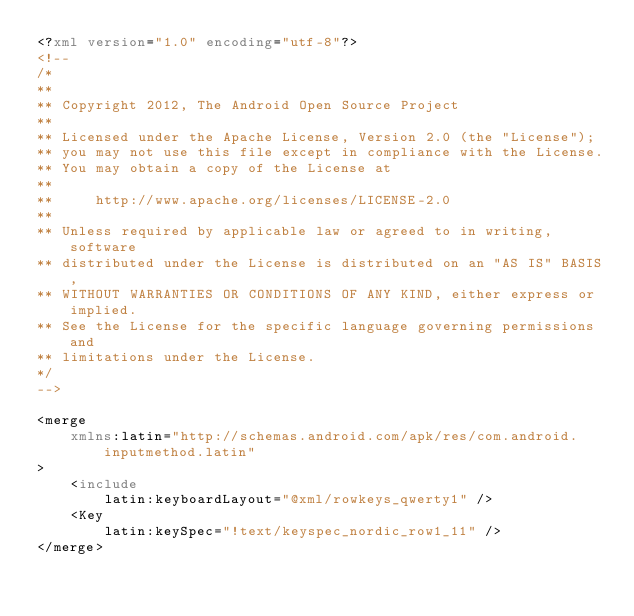<code> <loc_0><loc_0><loc_500><loc_500><_XML_><?xml version="1.0" encoding="utf-8"?>
<!--
/*
**
** Copyright 2012, The Android Open Source Project
**
** Licensed under the Apache License, Version 2.0 (the "License");
** you may not use this file except in compliance with the License.
** You may obtain a copy of the License at
**
**     http://www.apache.org/licenses/LICENSE-2.0
**
** Unless required by applicable law or agreed to in writing, software
** distributed under the License is distributed on an "AS IS" BASIS,
** WITHOUT WARRANTIES OR CONDITIONS OF ANY KIND, either express or implied.
** See the License for the specific language governing permissions and
** limitations under the License.
*/
-->

<merge
    xmlns:latin="http://schemas.android.com/apk/res/com.android.inputmethod.latin"
>
    <include
        latin:keyboardLayout="@xml/rowkeys_qwerty1" />
    <Key
        latin:keySpec="!text/keyspec_nordic_row1_11" />
</merge>
</code> 